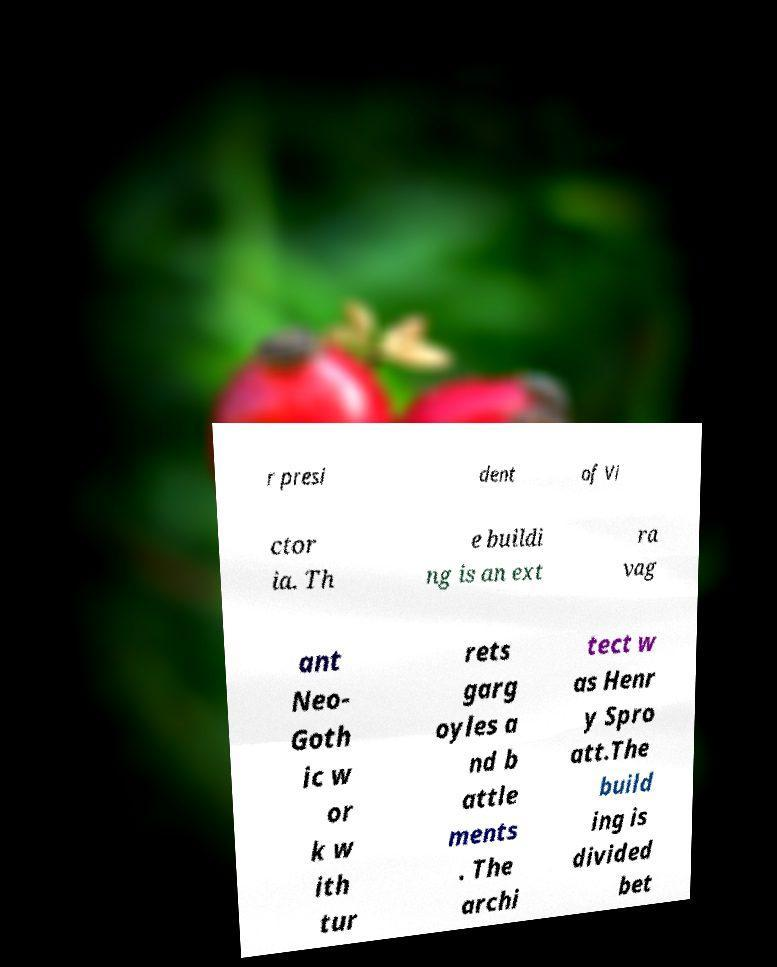Please identify and transcribe the text found in this image. r presi dent of Vi ctor ia. Th e buildi ng is an ext ra vag ant Neo- Goth ic w or k w ith tur rets garg oyles a nd b attle ments . The archi tect w as Henr y Spro att.The build ing is divided bet 